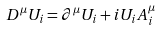Convert formula to latex. <formula><loc_0><loc_0><loc_500><loc_500>D ^ { \mu } U _ { i } = \partial ^ { \mu } U _ { i } + i U _ { i } A ^ { \mu } _ { i }</formula> 